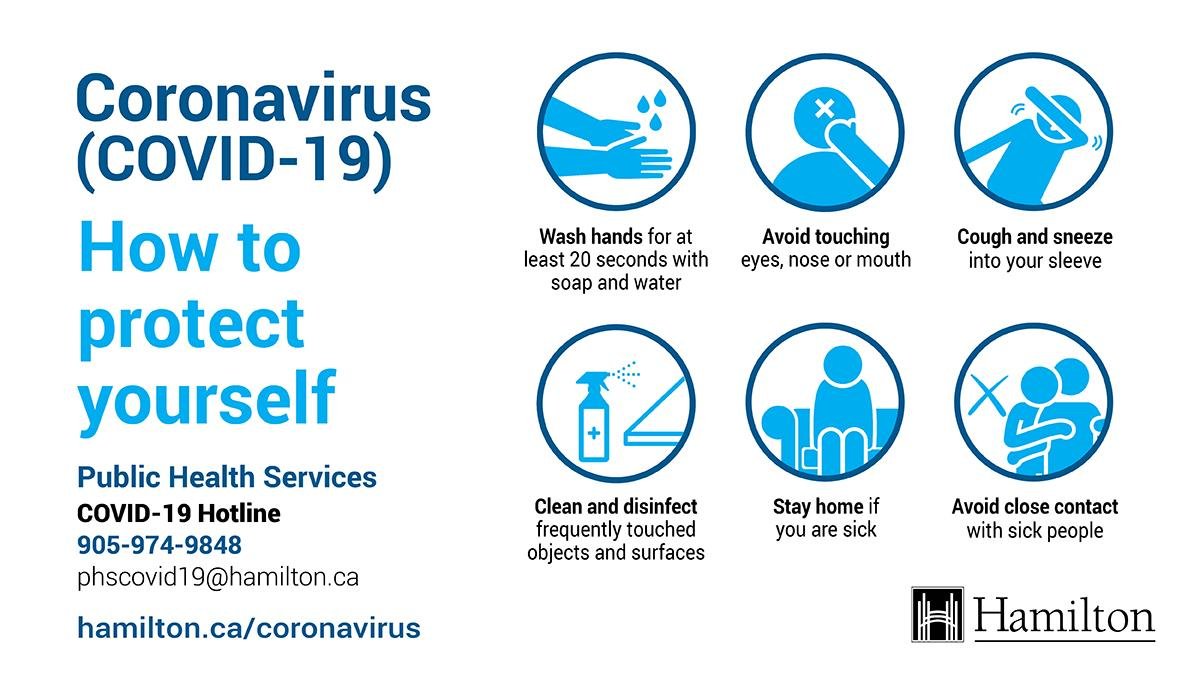Mention a couple of crucial points in this snapshot. According to the World Health Organization, it is recommended that individuals wash their hands for at least 20 seconds in order to effectively prevent the spread of COVID-19. 